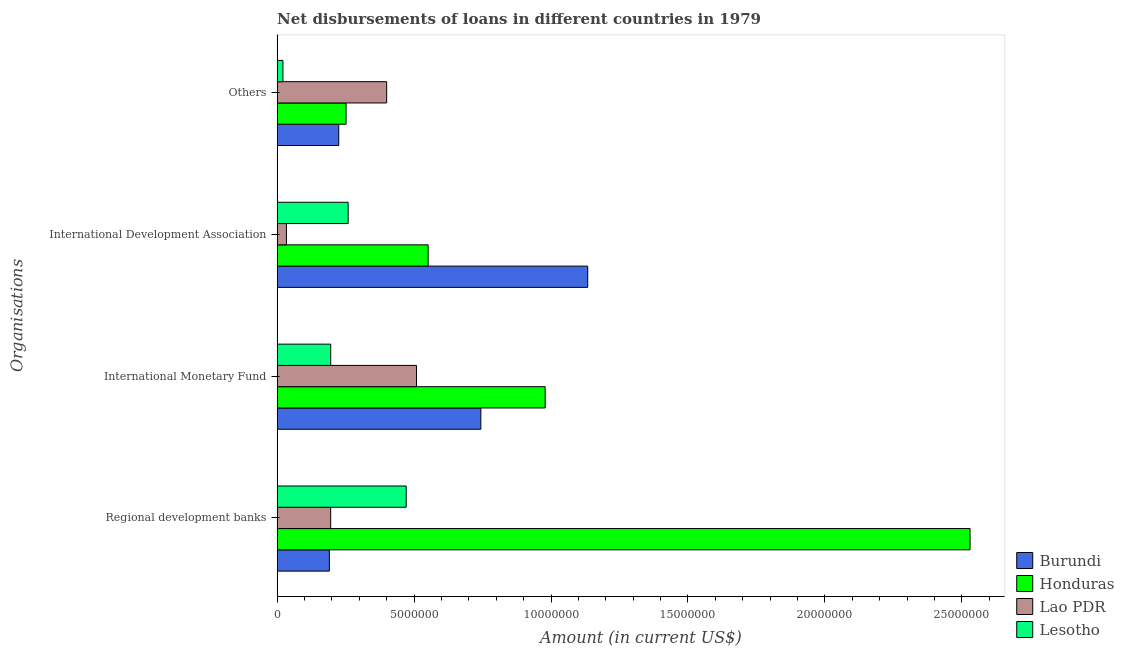Are the number of bars per tick equal to the number of legend labels?
Offer a terse response. Yes. How many bars are there on the 4th tick from the bottom?
Provide a succinct answer. 4. What is the label of the 2nd group of bars from the top?
Provide a succinct answer. International Development Association. What is the amount of loan disimbursed by regional development banks in Burundi?
Make the answer very short. 1.91e+06. Across all countries, what is the maximum amount of loan disimbursed by other organisations?
Give a very brief answer. 4.00e+06. Across all countries, what is the minimum amount of loan disimbursed by regional development banks?
Provide a succinct answer. 1.91e+06. In which country was the amount of loan disimbursed by international monetary fund maximum?
Your answer should be compact. Honduras. In which country was the amount of loan disimbursed by other organisations minimum?
Offer a terse response. Lesotho. What is the total amount of loan disimbursed by international development association in the graph?
Make the answer very short. 1.98e+07. What is the difference between the amount of loan disimbursed by other organisations in Lesotho and that in Lao PDR?
Make the answer very short. -3.79e+06. What is the difference between the amount of loan disimbursed by other organisations in Honduras and the amount of loan disimbursed by international monetary fund in Lao PDR?
Offer a terse response. -2.57e+06. What is the average amount of loan disimbursed by regional development banks per country?
Provide a short and direct response. 8.47e+06. What is the difference between the amount of loan disimbursed by regional development banks and amount of loan disimbursed by international monetary fund in Burundi?
Provide a short and direct response. -5.53e+06. In how many countries, is the amount of loan disimbursed by other organisations greater than 24000000 US$?
Keep it short and to the point. 0. What is the ratio of the amount of loan disimbursed by regional development banks in Burundi to that in Lesotho?
Ensure brevity in your answer.  0.4. Is the amount of loan disimbursed by international development association in Lesotho less than that in Burundi?
Give a very brief answer. Yes. What is the difference between the highest and the second highest amount of loan disimbursed by international development association?
Make the answer very short. 5.83e+06. What is the difference between the highest and the lowest amount of loan disimbursed by international monetary fund?
Give a very brief answer. 7.83e+06. Is the sum of the amount of loan disimbursed by international development association in Lesotho and Lao PDR greater than the maximum amount of loan disimbursed by other organisations across all countries?
Your response must be concise. No. Is it the case that in every country, the sum of the amount of loan disimbursed by regional development banks and amount of loan disimbursed by international monetary fund is greater than the sum of amount of loan disimbursed by international development association and amount of loan disimbursed by other organisations?
Offer a terse response. No. What does the 2nd bar from the top in Others represents?
Your answer should be very brief. Lao PDR. What does the 1st bar from the bottom in Others represents?
Offer a terse response. Burundi. Is it the case that in every country, the sum of the amount of loan disimbursed by regional development banks and amount of loan disimbursed by international monetary fund is greater than the amount of loan disimbursed by international development association?
Provide a succinct answer. No. Are all the bars in the graph horizontal?
Provide a succinct answer. Yes. Does the graph contain any zero values?
Your answer should be very brief. No. Does the graph contain grids?
Offer a very short reply. No. How many legend labels are there?
Provide a short and direct response. 4. How are the legend labels stacked?
Ensure brevity in your answer.  Vertical. What is the title of the graph?
Provide a short and direct response. Net disbursements of loans in different countries in 1979. What is the label or title of the X-axis?
Your response must be concise. Amount (in current US$). What is the label or title of the Y-axis?
Ensure brevity in your answer.  Organisations. What is the Amount (in current US$) of Burundi in Regional development banks?
Make the answer very short. 1.91e+06. What is the Amount (in current US$) of Honduras in Regional development banks?
Make the answer very short. 2.53e+07. What is the Amount (in current US$) of Lao PDR in Regional development banks?
Give a very brief answer. 1.96e+06. What is the Amount (in current US$) of Lesotho in Regional development banks?
Provide a succinct answer. 4.71e+06. What is the Amount (in current US$) in Burundi in International Monetary Fund?
Provide a succinct answer. 7.44e+06. What is the Amount (in current US$) in Honduras in International Monetary Fund?
Offer a very short reply. 9.79e+06. What is the Amount (in current US$) of Lao PDR in International Monetary Fund?
Provide a succinct answer. 5.09e+06. What is the Amount (in current US$) in Lesotho in International Monetary Fund?
Your answer should be compact. 1.96e+06. What is the Amount (in current US$) in Burundi in International Development Association?
Ensure brevity in your answer.  1.13e+07. What is the Amount (in current US$) of Honduras in International Development Association?
Offer a very short reply. 5.51e+06. What is the Amount (in current US$) in Lao PDR in International Development Association?
Give a very brief answer. 3.40e+05. What is the Amount (in current US$) of Lesotho in International Development Association?
Provide a succinct answer. 2.59e+06. What is the Amount (in current US$) of Burundi in Others?
Provide a short and direct response. 2.25e+06. What is the Amount (in current US$) in Honduras in Others?
Your response must be concise. 2.52e+06. What is the Amount (in current US$) in Lesotho in Others?
Ensure brevity in your answer.  2.12e+05. Across all Organisations, what is the maximum Amount (in current US$) in Burundi?
Make the answer very short. 1.13e+07. Across all Organisations, what is the maximum Amount (in current US$) of Honduras?
Your answer should be very brief. 2.53e+07. Across all Organisations, what is the maximum Amount (in current US$) of Lao PDR?
Provide a short and direct response. 5.09e+06. Across all Organisations, what is the maximum Amount (in current US$) of Lesotho?
Your answer should be very brief. 4.71e+06. Across all Organisations, what is the minimum Amount (in current US$) of Burundi?
Your answer should be very brief. 1.91e+06. Across all Organisations, what is the minimum Amount (in current US$) in Honduras?
Give a very brief answer. 2.52e+06. Across all Organisations, what is the minimum Amount (in current US$) in Lao PDR?
Ensure brevity in your answer.  3.40e+05. Across all Organisations, what is the minimum Amount (in current US$) in Lesotho?
Provide a succinct answer. 2.12e+05. What is the total Amount (in current US$) of Burundi in the graph?
Your response must be concise. 2.29e+07. What is the total Amount (in current US$) in Honduras in the graph?
Ensure brevity in your answer.  4.31e+07. What is the total Amount (in current US$) of Lao PDR in the graph?
Provide a succinct answer. 1.14e+07. What is the total Amount (in current US$) in Lesotho in the graph?
Your answer should be very brief. 9.48e+06. What is the difference between the Amount (in current US$) in Burundi in Regional development banks and that in International Monetary Fund?
Make the answer very short. -5.53e+06. What is the difference between the Amount (in current US$) of Honduras in Regional development banks and that in International Monetary Fund?
Your response must be concise. 1.55e+07. What is the difference between the Amount (in current US$) in Lao PDR in Regional development banks and that in International Monetary Fund?
Ensure brevity in your answer.  -3.13e+06. What is the difference between the Amount (in current US$) in Lesotho in Regional development banks and that in International Monetary Fund?
Make the answer very short. 2.76e+06. What is the difference between the Amount (in current US$) in Burundi in Regional development banks and that in International Development Association?
Your response must be concise. -9.43e+06. What is the difference between the Amount (in current US$) in Honduras in Regional development banks and that in International Development Association?
Your answer should be very brief. 1.98e+07. What is the difference between the Amount (in current US$) of Lao PDR in Regional development banks and that in International Development Association?
Offer a very short reply. 1.62e+06. What is the difference between the Amount (in current US$) in Lesotho in Regional development banks and that in International Development Association?
Your response must be concise. 2.12e+06. What is the difference between the Amount (in current US$) of Burundi in Regional development banks and that in Others?
Offer a terse response. -3.42e+05. What is the difference between the Amount (in current US$) in Honduras in Regional development banks and that in Others?
Offer a very short reply. 2.28e+07. What is the difference between the Amount (in current US$) of Lao PDR in Regional development banks and that in Others?
Offer a very short reply. -2.04e+06. What is the difference between the Amount (in current US$) of Lesotho in Regional development banks and that in Others?
Keep it short and to the point. 4.50e+06. What is the difference between the Amount (in current US$) of Burundi in International Monetary Fund and that in International Development Association?
Provide a succinct answer. -3.90e+06. What is the difference between the Amount (in current US$) in Honduras in International Monetary Fund and that in International Development Association?
Ensure brevity in your answer.  4.27e+06. What is the difference between the Amount (in current US$) of Lao PDR in International Monetary Fund and that in International Development Association?
Keep it short and to the point. 4.75e+06. What is the difference between the Amount (in current US$) in Lesotho in International Monetary Fund and that in International Development Association?
Your response must be concise. -6.36e+05. What is the difference between the Amount (in current US$) of Burundi in International Monetary Fund and that in Others?
Provide a short and direct response. 5.19e+06. What is the difference between the Amount (in current US$) of Honduras in International Monetary Fund and that in Others?
Your answer should be compact. 7.27e+06. What is the difference between the Amount (in current US$) in Lao PDR in International Monetary Fund and that in Others?
Provide a short and direct response. 1.09e+06. What is the difference between the Amount (in current US$) in Lesotho in International Monetary Fund and that in Others?
Your answer should be compact. 1.74e+06. What is the difference between the Amount (in current US$) in Burundi in International Development Association and that in Others?
Keep it short and to the point. 9.09e+06. What is the difference between the Amount (in current US$) in Honduras in International Development Association and that in Others?
Ensure brevity in your answer.  3.00e+06. What is the difference between the Amount (in current US$) of Lao PDR in International Development Association and that in Others?
Your answer should be compact. -3.66e+06. What is the difference between the Amount (in current US$) of Lesotho in International Development Association and that in Others?
Your answer should be compact. 2.38e+06. What is the difference between the Amount (in current US$) of Burundi in Regional development banks and the Amount (in current US$) of Honduras in International Monetary Fund?
Give a very brief answer. -7.88e+06. What is the difference between the Amount (in current US$) in Burundi in Regional development banks and the Amount (in current US$) in Lao PDR in International Monetary Fund?
Your answer should be very brief. -3.18e+06. What is the difference between the Amount (in current US$) of Burundi in Regional development banks and the Amount (in current US$) of Lesotho in International Monetary Fund?
Provide a short and direct response. -4.90e+04. What is the difference between the Amount (in current US$) of Honduras in Regional development banks and the Amount (in current US$) of Lao PDR in International Monetary Fund?
Your response must be concise. 2.02e+07. What is the difference between the Amount (in current US$) of Honduras in Regional development banks and the Amount (in current US$) of Lesotho in International Monetary Fund?
Offer a very short reply. 2.33e+07. What is the difference between the Amount (in current US$) of Lao PDR in Regional development banks and the Amount (in current US$) of Lesotho in International Monetary Fund?
Offer a very short reply. -2000. What is the difference between the Amount (in current US$) in Burundi in Regional development banks and the Amount (in current US$) in Honduras in International Development Association?
Ensure brevity in your answer.  -3.61e+06. What is the difference between the Amount (in current US$) of Burundi in Regional development banks and the Amount (in current US$) of Lao PDR in International Development Association?
Offer a terse response. 1.57e+06. What is the difference between the Amount (in current US$) of Burundi in Regional development banks and the Amount (in current US$) of Lesotho in International Development Association?
Your answer should be very brief. -6.85e+05. What is the difference between the Amount (in current US$) of Honduras in Regional development banks and the Amount (in current US$) of Lao PDR in International Development Association?
Provide a succinct answer. 2.50e+07. What is the difference between the Amount (in current US$) in Honduras in Regional development banks and the Amount (in current US$) in Lesotho in International Development Association?
Your response must be concise. 2.27e+07. What is the difference between the Amount (in current US$) in Lao PDR in Regional development banks and the Amount (in current US$) in Lesotho in International Development Association?
Offer a very short reply. -6.38e+05. What is the difference between the Amount (in current US$) of Burundi in Regional development banks and the Amount (in current US$) of Honduras in Others?
Your answer should be compact. -6.09e+05. What is the difference between the Amount (in current US$) of Burundi in Regional development banks and the Amount (in current US$) of Lao PDR in Others?
Offer a very short reply. -2.09e+06. What is the difference between the Amount (in current US$) of Burundi in Regional development banks and the Amount (in current US$) of Lesotho in Others?
Your answer should be very brief. 1.70e+06. What is the difference between the Amount (in current US$) in Honduras in Regional development banks and the Amount (in current US$) in Lao PDR in Others?
Offer a very short reply. 2.13e+07. What is the difference between the Amount (in current US$) in Honduras in Regional development banks and the Amount (in current US$) in Lesotho in Others?
Offer a very short reply. 2.51e+07. What is the difference between the Amount (in current US$) in Lao PDR in Regional development banks and the Amount (in current US$) in Lesotho in Others?
Offer a very short reply. 1.74e+06. What is the difference between the Amount (in current US$) in Burundi in International Monetary Fund and the Amount (in current US$) in Honduras in International Development Association?
Offer a very short reply. 1.92e+06. What is the difference between the Amount (in current US$) in Burundi in International Monetary Fund and the Amount (in current US$) in Lao PDR in International Development Association?
Ensure brevity in your answer.  7.10e+06. What is the difference between the Amount (in current US$) in Burundi in International Monetary Fund and the Amount (in current US$) in Lesotho in International Development Association?
Give a very brief answer. 4.84e+06. What is the difference between the Amount (in current US$) of Honduras in International Monetary Fund and the Amount (in current US$) of Lao PDR in International Development Association?
Give a very brief answer. 9.45e+06. What is the difference between the Amount (in current US$) of Honduras in International Monetary Fund and the Amount (in current US$) of Lesotho in International Development Association?
Your answer should be compact. 7.19e+06. What is the difference between the Amount (in current US$) in Lao PDR in International Monetary Fund and the Amount (in current US$) in Lesotho in International Development Association?
Make the answer very short. 2.50e+06. What is the difference between the Amount (in current US$) of Burundi in International Monetary Fund and the Amount (in current US$) of Honduras in Others?
Your answer should be compact. 4.92e+06. What is the difference between the Amount (in current US$) of Burundi in International Monetary Fund and the Amount (in current US$) of Lao PDR in Others?
Provide a short and direct response. 3.44e+06. What is the difference between the Amount (in current US$) in Burundi in International Monetary Fund and the Amount (in current US$) in Lesotho in Others?
Make the answer very short. 7.23e+06. What is the difference between the Amount (in current US$) in Honduras in International Monetary Fund and the Amount (in current US$) in Lao PDR in Others?
Keep it short and to the point. 5.79e+06. What is the difference between the Amount (in current US$) of Honduras in International Monetary Fund and the Amount (in current US$) of Lesotho in Others?
Ensure brevity in your answer.  9.58e+06. What is the difference between the Amount (in current US$) in Lao PDR in International Monetary Fund and the Amount (in current US$) in Lesotho in Others?
Make the answer very short. 4.88e+06. What is the difference between the Amount (in current US$) in Burundi in International Development Association and the Amount (in current US$) in Honduras in Others?
Keep it short and to the point. 8.82e+06. What is the difference between the Amount (in current US$) of Burundi in International Development Association and the Amount (in current US$) of Lao PDR in Others?
Ensure brevity in your answer.  7.34e+06. What is the difference between the Amount (in current US$) of Burundi in International Development Association and the Amount (in current US$) of Lesotho in Others?
Your answer should be compact. 1.11e+07. What is the difference between the Amount (in current US$) of Honduras in International Development Association and the Amount (in current US$) of Lao PDR in Others?
Provide a short and direct response. 1.51e+06. What is the difference between the Amount (in current US$) in Honduras in International Development Association and the Amount (in current US$) in Lesotho in Others?
Provide a succinct answer. 5.30e+06. What is the difference between the Amount (in current US$) in Lao PDR in International Development Association and the Amount (in current US$) in Lesotho in Others?
Provide a short and direct response. 1.28e+05. What is the average Amount (in current US$) in Burundi per Organisations?
Your answer should be very brief. 5.73e+06. What is the average Amount (in current US$) of Honduras per Organisations?
Provide a succinct answer. 1.08e+07. What is the average Amount (in current US$) of Lao PDR per Organisations?
Make the answer very short. 2.85e+06. What is the average Amount (in current US$) of Lesotho per Organisations?
Ensure brevity in your answer.  2.37e+06. What is the difference between the Amount (in current US$) in Burundi and Amount (in current US$) in Honduras in Regional development banks?
Your answer should be very brief. -2.34e+07. What is the difference between the Amount (in current US$) of Burundi and Amount (in current US$) of Lao PDR in Regional development banks?
Offer a very short reply. -4.70e+04. What is the difference between the Amount (in current US$) of Burundi and Amount (in current US$) of Lesotho in Regional development banks?
Make the answer very short. -2.80e+06. What is the difference between the Amount (in current US$) of Honduras and Amount (in current US$) of Lao PDR in Regional development banks?
Offer a very short reply. 2.33e+07. What is the difference between the Amount (in current US$) of Honduras and Amount (in current US$) of Lesotho in Regional development banks?
Your answer should be very brief. 2.06e+07. What is the difference between the Amount (in current US$) of Lao PDR and Amount (in current US$) of Lesotho in Regional development banks?
Provide a succinct answer. -2.76e+06. What is the difference between the Amount (in current US$) in Burundi and Amount (in current US$) in Honduras in International Monetary Fund?
Give a very brief answer. -2.35e+06. What is the difference between the Amount (in current US$) of Burundi and Amount (in current US$) of Lao PDR in International Monetary Fund?
Provide a succinct answer. 2.35e+06. What is the difference between the Amount (in current US$) of Burundi and Amount (in current US$) of Lesotho in International Monetary Fund?
Offer a terse response. 5.48e+06. What is the difference between the Amount (in current US$) of Honduras and Amount (in current US$) of Lao PDR in International Monetary Fund?
Provide a succinct answer. 4.70e+06. What is the difference between the Amount (in current US$) in Honduras and Amount (in current US$) in Lesotho in International Monetary Fund?
Provide a succinct answer. 7.83e+06. What is the difference between the Amount (in current US$) of Lao PDR and Amount (in current US$) of Lesotho in International Monetary Fund?
Offer a very short reply. 3.13e+06. What is the difference between the Amount (in current US$) of Burundi and Amount (in current US$) of Honduras in International Development Association?
Offer a terse response. 5.83e+06. What is the difference between the Amount (in current US$) in Burundi and Amount (in current US$) in Lao PDR in International Development Association?
Your response must be concise. 1.10e+07. What is the difference between the Amount (in current US$) in Burundi and Amount (in current US$) in Lesotho in International Development Association?
Provide a succinct answer. 8.75e+06. What is the difference between the Amount (in current US$) of Honduras and Amount (in current US$) of Lao PDR in International Development Association?
Provide a succinct answer. 5.17e+06. What is the difference between the Amount (in current US$) in Honduras and Amount (in current US$) in Lesotho in International Development Association?
Ensure brevity in your answer.  2.92e+06. What is the difference between the Amount (in current US$) in Lao PDR and Amount (in current US$) in Lesotho in International Development Association?
Your answer should be compact. -2.25e+06. What is the difference between the Amount (in current US$) of Burundi and Amount (in current US$) of Honduras in Others?
Provide a succinct answer. -2.67e+05. What is the difference between the Amount (in current US$) in Burundi and Amount (in current US$) in Lao PDR in Others?
Provide a short and direct response. -1.75e+06. What is the difference between the Amount (in current US$) in Burundi and Amount (in current US$) in Lesotho in Others?
Make the answer very short. 2.04e+06. What is the difference between the Amount (in current US$) in Honduras and Amount (in current US$) in Lao PDR in Others?
Your answer should be compact. -1.48e+06. What is the difference between the Amount (in current US$) in Honduras and Amount (in current US$) in Lesotho in Others?
Offer a very short reply. 2.30e+06. What is the difference between the Amount (in current US$) of Lao PDR and Amount (in current US$) of Lesotho in Others?
Your response must be concise. 3.79e+06. What is the ratio of the Amount (in current US$) in Burundi in Regional development banks to that in International Monetary Fund?
Your answer should be compact. 0.26. What is the ratio of the Amount (in current US$) of Honduras in Regional development banks to that in International Monetary Fund?
Provide a succinct answer. 2.59. What is the ratio of the Amount (in current US$) of Lao PDR in Regional development banks to that in International Monetary Fund?
Provide a succinct answer. 0.38. What is the ratio of the Amount (in current US$) in Lesotho in Regional development banks to that in International Monetary Fund?
Ensure brevity in your answer.  2.41. What is the ratio of the Amount (in current US$) of Burundi in Regional development banks to that in International Development Association?
Your answer should be very brief. 0.17. What is the ratio of the Amount (in current US$) of Honduras in Regional development banks to that in International Development Association?
Offer a terse response. 4.59. What is the ratio of the Amount (in current US$) of Lao PDR in Regional development banks to that in International Development Association?
Your response must be concise. 5.75. What is the ratio of the Amount (in current US$) of Lesotho in Regional development banks to that in International Development Association?
Offer a terse response. 1.82. What is the ratio of the Amount (in current US$) in Burundi in Regional development banks to that in Others?
Ensure brevity in your answer.  0.85. What is the ratio of the Amount (in current US$) of Honduras in Regional development banks to that in Others?
Provide a short and direct response. 10.05. What is the ratio of the Amount (in current US$) of Lao PDR in Regional development banks to that in Others?
Your answer should be very brief. 0.49. What is the ratio of the Amount (in current US$) of Lesotho in Regional development banks to that in Others?
Make the answer very short. 22.23. What is the ratio of the Amount (in current US$) of Burundi in International Monetary Fund to that in International Development Association?
Offer a terse response. 0.66. What is the ratio of the Amount (in current US$) in Honduras in International Monetary Fund to that in International Development Association?
Your answer should be very brief. 1.77. What is the ratio of the Amount (in current US$) in Lao PDR in International Monetary Fund to that in International Development Association?
Make the answer very short. 14.97. What is the ratio of the Amount (in current US$) in Lesotho in International Monetary Fund to that in International Development Association?
Offer a very short reply. 0.75. What is the ratio of the Amount (in current US$) of Burundi in International Monetary Fund to that in Others?
Your answer should be compact. 3.31. What is the ratio of the Amount (in current US$) in Honduras in International Monetary Fund to that in Others?
Ensure brevity in your answer.  3.89. What is the ratio of the Amount (in current US$) of Lao PDR in International Monetary Fund to that in Others?
Give a very brief answer. 1.27. What is the ratio of the Amount (in current US$) of Lesotho in International Monetary Fund to that in Others?
Make the answer very short. 9.23. What is the ratio of the Amount (in current US$) in Burundi in International Development Association to that in Others?
Make the answer very short. 5.04. What is the ratio of the Amount (in current US$) of Honduras in International Development Association to that in Others?
Offer a very short reply. 2.19. What is the ratio of the Amount (in current US$) in Lao PDR in International Development Association to that in Others?
Keep it short and to the point. 0.09. What is the ratio of the Amount (in current US$) of Lesotho in International Development Association to that in Others?
Make the answer very short. 12.23. What is the difference between the highest and the second highest Amount (in current US$) of Burundi?
Offer a very short reply. 3.90e+06. What is the difference between the highest and the second highest Amount (in current US$) in Honduras?
Give a very brief answer. 1.55e+07. What is the difference between the highest and the second highest Amount (in current US$) in Lao PDR?
Offer a very short reply. 1.09e+06. What is the difference between the highest and the second highest Amount (in current US$) of Lesotho?
Provide a short and direct response. 2.12e+06. What is the difference between the highest and the lowest Amount (in current US$) of Burundi?
Make the answer very short. 9.43e+06. What is the difference between the highest and the lowest Amount (in current US$) of Honduras?
Ensure brevity in your answer.  2.28e+07. What is the difference between the highest and the lowest Amount (in current US$) of Lao PDR?
Keep it short and to the point. 4.75e+06. What is the difference between the highest and the lowest Amount (in current US$) of Lesotho?
Provide a succinct answer. 4.50e+06. 